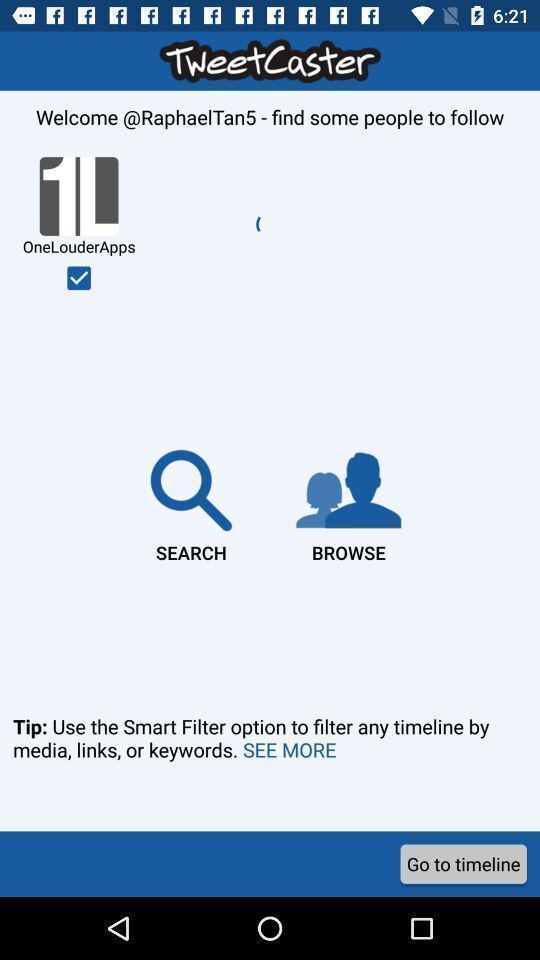Give me a summary of this screen capture. Welcome page for a social app. 